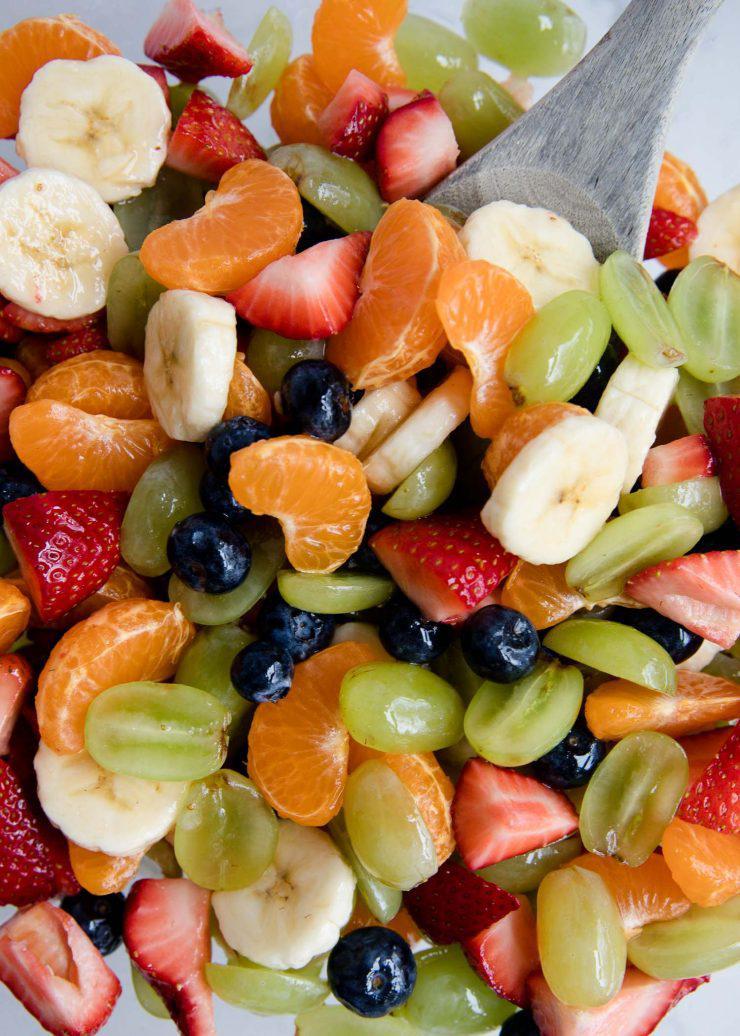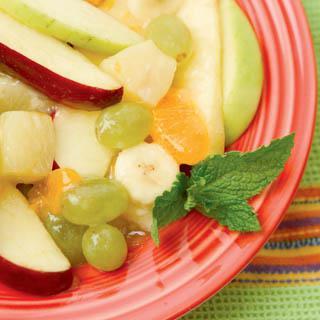The first image is the image on the left, the second image is the image on the right. Analyze the images presented: Is the assertion "A banana with its peel on is next to a bunch of reddish grapes in the right image." valid? Answer yes or no. No. The first image is the image on the left, the second image is the image on the right. For the images displayed, is the sentence "Some of the fruit is clearly in a bowl." factually correct? Answer yes or no. No. 